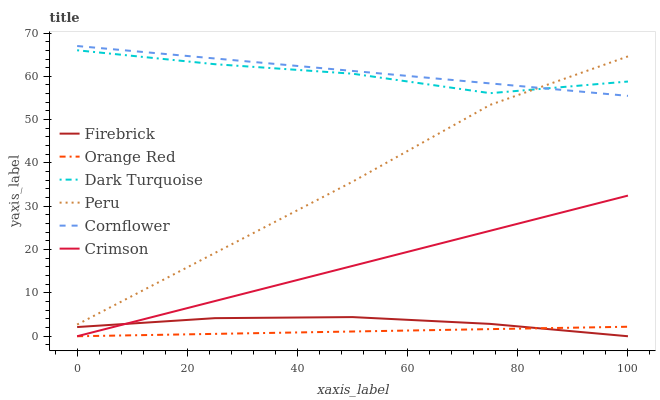Does Orange Red have the minimum area under the curve?
Answer yes or no. Yes. Does Cornflower have the maximum area under the curve?
Answer yes or no. Yes. Does Dark Turquoise have the minimum area under the curve?
Answer yes or no. No. Does Dark Turquoise have the maximum area under the curve?
Answer yes or no. No. Is Orange Red the smoothest?
Answer yes or no. Yes. Is Dark Turquoise the roughest?
Answer yes or no. Yes. Is Firebrick the smoothest?
Answer yes or no. No. Is Firebrick the roughest?
Answer yes or no. No. Does Firebrick have the lowest value?
Answer yes or no. Yes. Does Dark Turquoise have the lowest value?
Answer yes or no. No. Does Cornflower have the highest value?
Answer yes or no. Yes. Does Dark Turquoise have the highest value?
Answer yes or no. No. Is Crimson less than Peru?
Answer yes or no. Yes. Is Dark Turquoise greater than Firebrick?
Answer yes or no. Yes. Does Peru intersect Cornflower?
Answer yes or no. Yes. Is Peru less than Cornflower?
Answer yes or no. No. Is Peru greater than Cornflower?
Answer yes or no. No. Does Crimson intersect Peru?
Answer yes or no. No. 